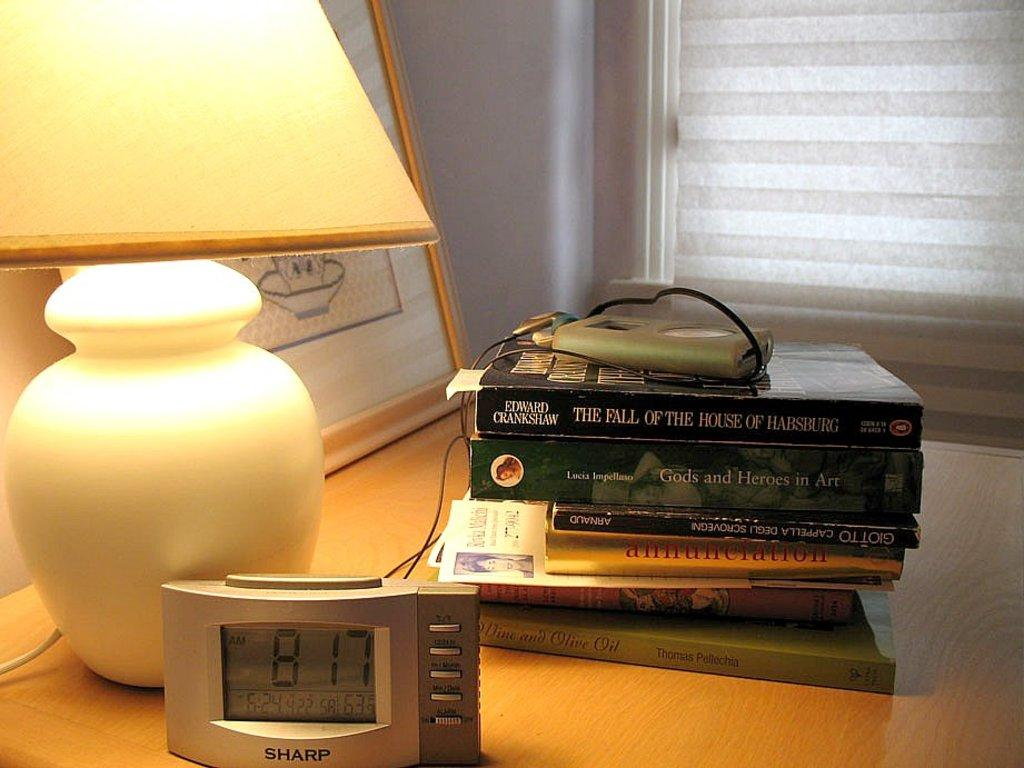<image>
Render a clear and concise summary of the photo. A digital clock reads 8:17 and sits on a table with a lamp. 